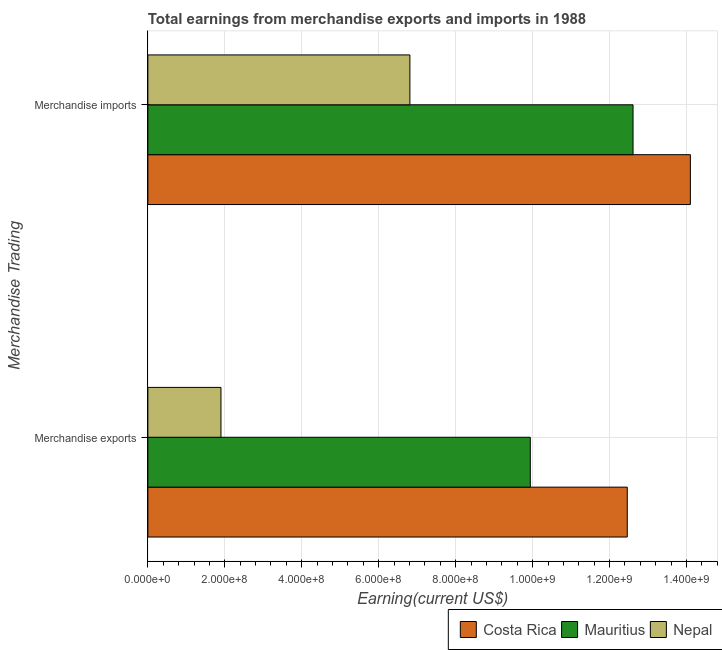How many different coloured bars are there?
Make the answer very short. 3. Are the number of bars per tick equal to the number of legend labels?
Your answer should be very brief. Yes. What is the earnings from merchandise exports in Nepal?
Keep it short and to the point. 1.90e+08. Across all countries, what is the maximum earnings from merchandise imports?
Your response must be concise. 1.41e+09. Across all countries, what is the minimum earnings from merchandise imports?
Offer a terse response. 6.81e+08. In which country was the earnings from merchandise imports maximum?
Provide a short and direct response. Costa Rica. In which country was the earnings from merchandise exports minimum?
Your answer should be very brief. Nepal. What is the total earnings from merchandise imports in the graph?
Your answer should be very brief. 3.35e+09. What is the difference between the earnings from merchandise exports in Costa Rica and that in Nepal?
Keep it short and to the point. 1.06e+09. What is the difference between the earnings from merchandise exports in Mauritius and the earnings from merchandise imports in Nepal?
Your answer should be very brief. 3.13e+08. What is the average earnings from merchandise exports per country?
Provide a succinct answer. 8.10e+08. What is the difference between the earnings from merchandise exports and earnings from merchandise imports in Costa Rica?
Offer a very short reply. -1.64e+08. In how many countries, is the earnings from merchandise exports greater than 280000000 US$?
Ensure brevity in your answer.  2. What is the ratio of the earnings from merchandise imports in Mauritius to that in Nepal?
Ensure brevity in your answer.  1.85. What does the 2nd bar from the bottom in Merchandise exports represents?
Give a very brief answer. Mauritius. Are all the bars in the graph horizontal?
Your response must be concise. Yes. Are the values on the major ticks of X-axis written in scientific E-notation?
Your answer should be compact. Yes. Where does the legend appear in the graph?
Your answer should be very brief. Bottom right. What is the title of the graph?
Make the answer very short. Total earnings from merchandise exports and imports in 1988. Does "Gambia, The" appear as one of the legend labels in the graph?
Offer a very short reply. No. What is the label or title of the X-axis?
Provide a short and direct response. Earning(current US$). What is the label or title of the Y-axis?
Make the answer very short. Merchandise Trading. What is the Earning(current US$) in Costa Rica in Merchandise exports?
Provide a succinct answer. 1.25e+09. What is the Earning(current US$) in Mauritius in Merchandise exports?
Your response must be concise. 9.94e+08. What is the Earning(current US$) in Nepal in Merchandise exports?
Offer a terse response. 1.90e+08. What is the Earning(current US$) of Costa Rica in Merchandise imports?
Ensure brevity in your answer.  1.41e+09. What is the Earning(current US$) of Mauritius in Merchandise imports?
Give a very brief answer. 1.26e+09. What is the Earning(current US$) of Nepal in Merchandise imports?
Ensure brevity in your answer.  6.81e+08. Across all Merchandise Trading, what is the maximum Earning(current US$) of Costa Rica?
Give a very brief answer. 1.41e+09. Across all Merchandise Trading, what is the maximum Earning(current US$) of Mauritius?
Offer a terse response. 1.26e+09. Across all Merchandise Trading, what is the maximum Earning(current US$) of Nepal?
Provide a short and direct response. 6.81e+08. Across all Merchandise Trading, what is the minimum Earning(current US$) in Costa Rica?
Offer a very short reply. 1.25e+09. Across all Merchandise Trading, what is the minimum Earning(current US$) in Mauritius?
Provide a short and direct response. 9.94e+08. Across all Merchandise Trading, what is the minimum Earning(current US$) of Nepal?
Offer a very short reply. 1.90e+08. What is the total Earning(current US$) in Costa Rica in the graph?
Offer a very short reply. 2.66e+09. What is the total Earning(current US$) of Mauritius in the graph?
Make the answer very short. 2.26e+09. What is the total Earning(current US$) of Nepal in the graph?
Your answer should be compact. 8.71e+08. What is the difference between the Earning(current US$) in Costa Rica in Merchandise exports and that in Merchandise imports?
Keep it short and to the point. -1.64e+08. What is the difference between the Earning(current US$) in Mauritius in Merchandise exports and that in Merchandise imports?
Offer a very short reply. -2.67e+08. What is the difference between the Earning(current US$) in Nepal in Merchandise exports and that in Merchandise imports?
Your response must be concise. -4.91e+08. What is the difference between the Earning(current US$) in Costa Rica in Merchandise exports and the Earning(current US$) in Mauritius in Merchandise imports?
Offer a terse response. -1.50e+07. What is the difference between the Earning(current US$) of Costa Rica in Merchandise exports and the Earning(current US$) of Nepal in Merchandise imports?
Provide a succinct answer. 5.65e+08. What is the difference between the Earning(current US$) of Mauritius in Merchandise exports and the Earning(current US$) of Nepal in Merchandise imports?
Give a very brief answer. 3.13e+08. What is the average Earning(current US$) in Costa Rica per Merchandise Trading?
Your answer should be very brief. 1.33e+09. What is the average Earning(current US$) in Mauritius per Merchandise Trading?
Make the answer very short. 1.13e+09. What is the average Earning(current US$) in Nepal per Merchandise Trading?
Your response must be concise. 4.36e+08. What is the difference between the Earning(current US$) of Costa Rica and Earning(current US$) of Mauritius in Merchandise exports?
Make the answer very short. 2.52e+08. What is the difference between the Earning(current US$) in Costa Rica and Earning(current US$) in Nepal in Merchandise exports?
Ensure brevity in your answer.  1.06e+09. What is the difference between the Earning(current US$) in Mauritius and Earning(current US$) in Nepal in Merchandise exports?
Your answer should be compact. 8.04e+08. What is the difference between the Earning(current US$) of Costa Rica and Earning(current US$) of Mauritius in Merchandise imports?
Keep it short and to the point. 1.49e+08. What is the difference between the Earning(current US$) in Costa Rica and Earning(current US$) in Nepal in Merchandise imports?
Provide a succinct answer. 7.29e+08. What is the difference between the Earning(current US$) of Mauritius and Earning(current US$) of Nepal in Merchandise imports?
Make the answer very short. 5.80e+08. What is the ratio of the Earning(current US$) of Costa Rica in Merchandise exports to that in Merchandise imports?
Provide a short and direct response. 0.88. What is the ratio of the Earning(current US$) in Mauritius in Merchandise exports to that in Merchandise imports?
Your response must be concise. 0.79. What is the ratio of the Earning(current US$) of Nepal in Merchandise exports to that in Merchandise imports?
Provide a short and direct response. 0.28. What is the difference between the highest and the second highest Earning(current US$) in Costa Rica?
Ensure brevity in your answer.  1.64e+08. What is the difference between the highest and the second highest Earning(current US$) of Mauritius?
Provide a succinct answer. 2.67e+08. What is the difference between the highest and the second highest Earning(current US$) of Nepal?
Ensure brevity in your answer.  4.91e+08. What is the difference between the highest and the lowest Earning(current US$) in Costa Rica?
Offer a very short reply. 1.64e+08. What is the difference between the highest and the lowest Earning(current US$) of Mauritius?
Provide a short and direct response. 2.67e+08. What is the difference between the highest and the lowest Earning(current US$) in Nepal?
Ensure brevity in your answer.  4.91e+08. 